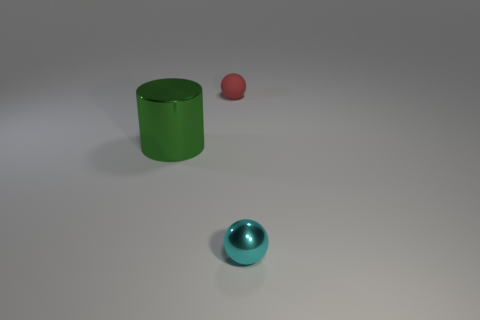Add 2 big green cylinders. How many objects exist? 5 Subtract all spheres. How many objects are left? 1 Subtract 0 blue blocks. How many objects are left? 3 Subtract all green things. Subtract all tiny cyan spheres. How many objects are left? 1 Add 3 big things. How many big things are left? 4 Add 3 tiny gray metal cubes. How many tiny gray metal cubes exist? 3 